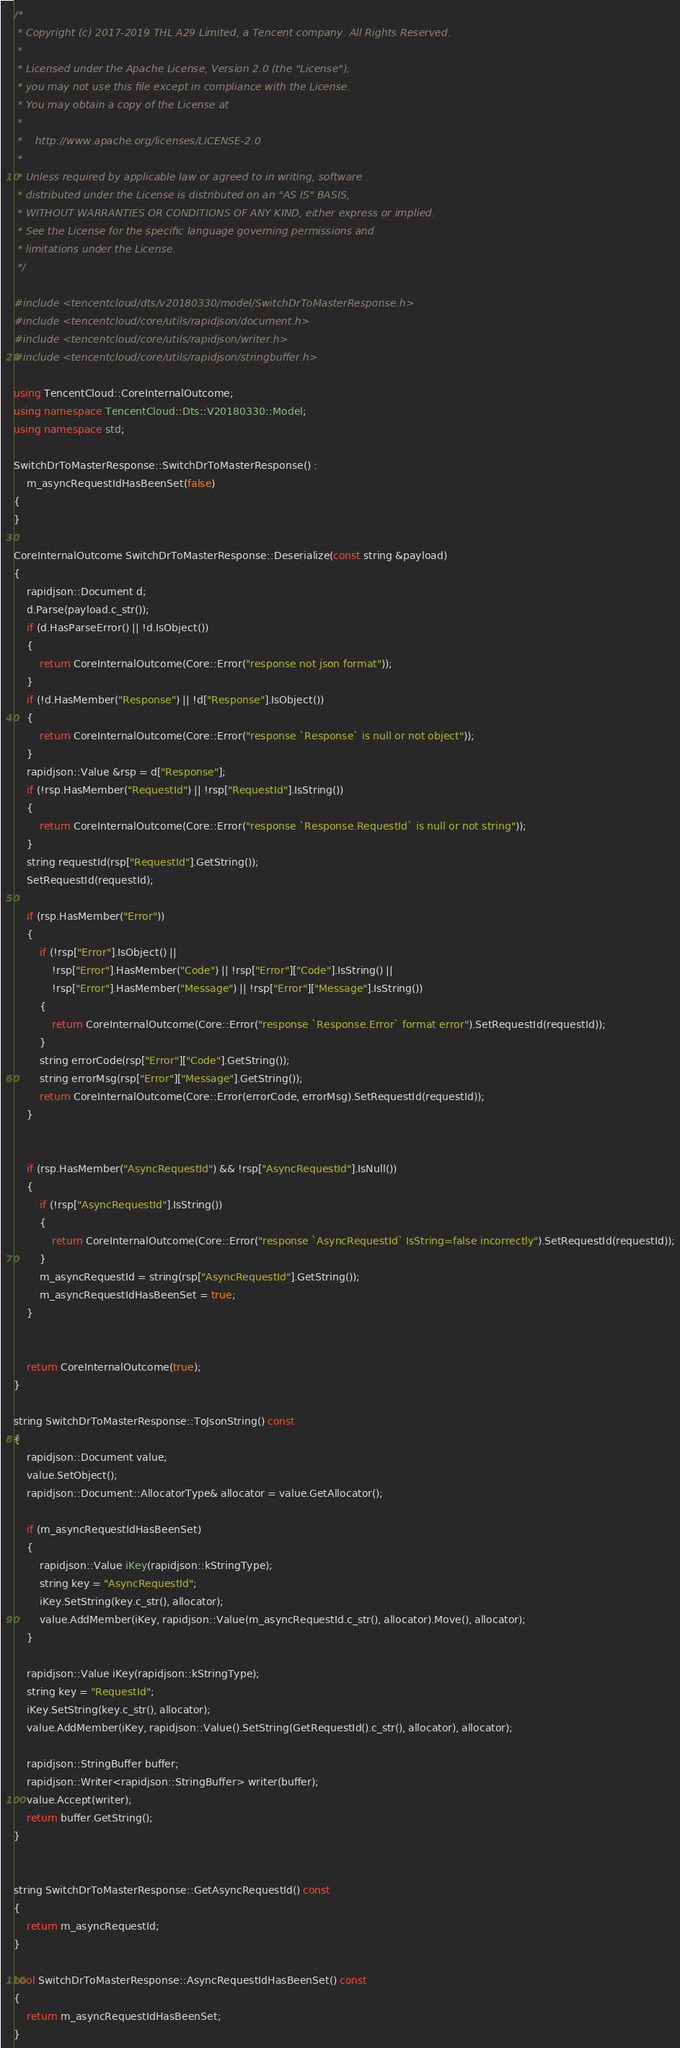Convert code to text. <code><loc_0><loc_0><loc_500><loc_500><_C++_>/*
 * Copyright (c) 2017-2019 THL A29 Limited, a Tencent company. All Rights Reserved.
 *
 * Licensed under the Apache License, Version 2.0 (the "License");
 * you may not use this file except in compliance with the License.
 * You may obtain a copy of the License at
 *
 *    http://www.apache.org/licenses/LICENSE-2.0
 *
 * Unless required by applicable law or agreed to in writing, software
 * distributed under the License is distributed on an "AS IS" BASIS,
 * WITHOUT WARRANTIES OR CONDITIONS OF ANY KIND, either express or implied.
 * See the License for the specific language governing permissions and
 * limitations under the License.
 */

#include <tencentcloud/dts/v20180330/model/SwitchDrToMasterResponse.h>
#include <tencentcloud/core/utils/rapidjson/document.h>
#include <tencentcloud/core/utils/rapidjson/writer.h>
#include <tencentcloud/core/utils/rapidjson/stringbuffer.h>

using TencentCloud::CoreInternalOutcome;
using namespace TencentCloud::Dts::V20180330::Model;
using namespace std;

SwitchDrToMasterResponse::SwitchDrToMasterResponse() :
    m_asyncRequestIdHasBeenSet(false)
{
}

CoreInternalOutcome SwitchDrToMasterResponse::Deserialize(const string &payload)
{
    rapidjson::Document d;
    d.Parse(payload.c_str());
    if (d.HasParseError() || !d.IsObject())
    {
        return CoreInternalOutcome(Core::Error("response not json format"));
    }
    if (!d.HasMember("Response") || !d["Response"].IsObject())
    {
        return CoreInternalOutcome(Core::Error("response `Response` is null or not object"));
    }
    rapidjson::Value &rsp = d["Response"];
    if (!rsp.HasMember("RequestId") || !rsp["RequestId"].IsString())
    {
        return CoreInternalOutcome(Core::Error("response `Response.RequestId` is null or not string"));
    }
    string requestId(rsp["RequestId"].GetString());
    SetRequestId(requestId);

    if (rsp.HasMember("Error"))
    {
        if (!rsp["Error"].IsObject() ||
            !rsp["Error"].HasMember("Code") || !rsp["Error"]["Code"].IsString() ||
            !rsp["Error"].HasMember("Message") || !rsp["Error"]["Message"].IsString())
        {
            return CoreInternalOutcome(Core::Error("response `Response.Error` format error").SetRequestId(requestId));
        }
        string errorCode(rsp["Error"]["Code"].GetString());
        string errorMsg(rsp["Error"]["Message"].GetString());
        return CoreInternalOutcome(Core::Error(errorCode, errorMsg).SetRequestId(requestId));
    }


    if (rsp.HasMember("AsyncRequestId") && !rsp["AsyncRequestId"].IsNull())
    {
        if (!rsp["AsyncRequestId"].IsString())
        {
            return CoreInternalOutcome(Core::Error("response `AsyncRequestId` IsString=false incorrectly").SetRequestId(requestId));
        }
        m_asyncRequestId = string(rsp["AsyncRequestId"].GetString());
        m_asyncRequestIdHasBeenSet = true;
    }


    return CoreInternalOutcome(true);
}

string SwitchDrToMasterResponse::ToJsonString() const
{
    rapidjson::Document value;
    value.SetObject();
    rapidjson::Document::AllocatorType& allocator = value.GetAllocator();

    if (m_asyncRequestIdHasBeenSet)
    {
        rapidjson::Value iKey(rapidjson::kStringType);
        string key = "AsyncRequestId";
        iKey.SetString(key.c_str(), allocator);
        value.AddMember(iKey, rapidjson::Value(m_asyncRequestId.c_str(), allocator).Move(), allocator);
    }

    rapidjson::Value iKey(rapidjson::kStringType);
    string key = "RequestId";
    iKey.SetString(key.c_str(), allocator);
    value.AddMember(iKey, rapidjson::Value().SetString(GetRequestId().c_str(), allocator), allocator);
    
    rapidjson::StringBuffer buffer;
    rapidjson::Writer<rapidjson::StringBuffer> writer(buffer);
    value.Accept(writer);
    return buffer.GetString();
}


string SwitchDrToMasterResponse::GetAsyncRequestId() const
{
    return m_asyncRequestId;
}

bool SwitchDrToMasterResponse::AsyncRequestIdHasBeenSet() const
{
    return m_asyncRequestIdHasBeenSet;
}


</code> 